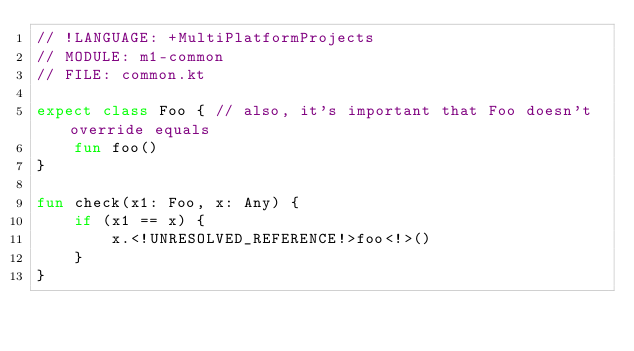<code> <loc_0><loc_0><loc_500><loc_500><_Kotlin_>// !LANGUAGE: +MultiPlatformProjects
// MODULE: m1-common
// FILE: common.kt

expect class Foo { // also, it's important that Foo doesn't override equals
    fun foo()
}

fun check(x1: Foo, x: Any) {
    if (x1 == x) {
        x.<!UNRESOLVED_REFERENCE!>foo<!>()
    }
}
</code> 